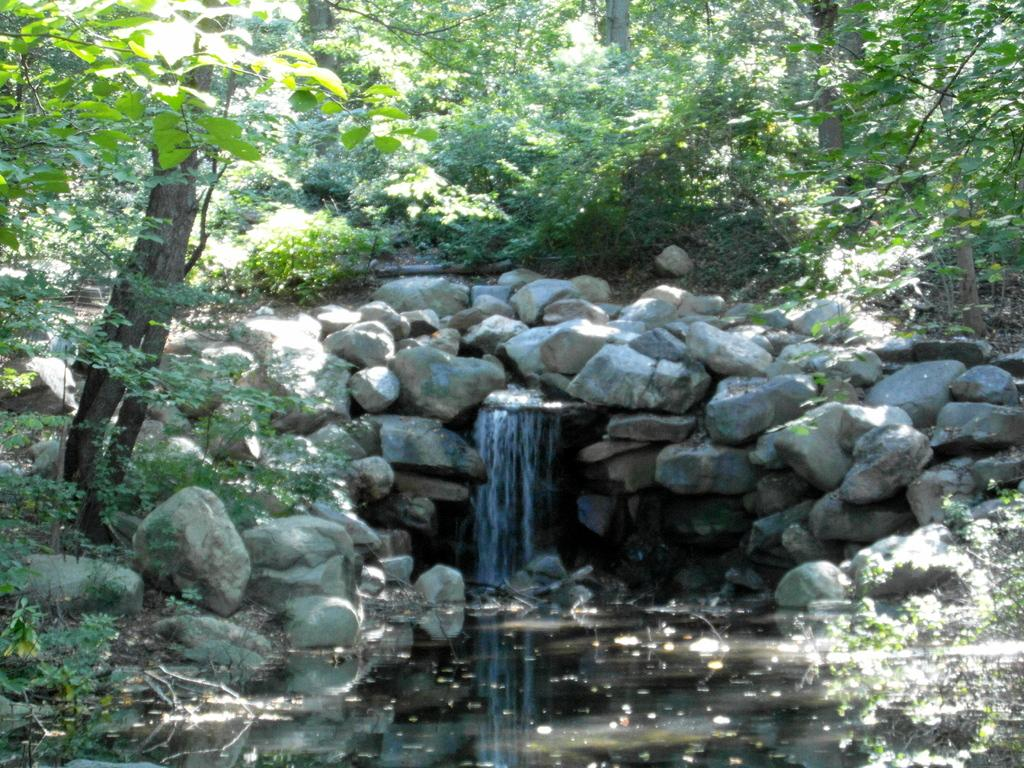What natural feature is the main subject of the image? There is a waterfall in the image. What type of geological formation can be seen in the image? Stones are present in the image. What type of vegetation is visible in the image? Trees are visible in the image. What is at the bottom of the waterfall in the image? There is water at the bottom of the image. How does the channel attack the control in the image? There is no channel, attack, or control present in the image. The image features a waterfall, stones, trees, and water at the bottom. 